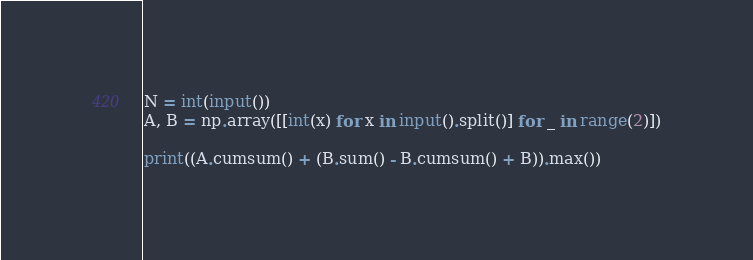<code> <loc_0><loc_0><loc_500><loc_500><_Python_>N = int(input())
A, B = np.array([[int(x) for x in input().split()] for _ in range(2)])

print((A.cumsum() + (B.sum() - B.cumsum() + B)).max())</code> 